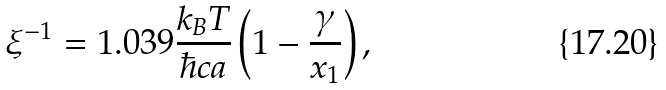Convert formula to latex. <formula><loc_0><loc_0><loc_500><loc_500>\xi ^ { - 1 } = 1 . 0 3 9 \frac { k _ { B } T } { \hbar { c } a } \left ( 1 - \frac { \gamma } { x _ { 1 } } \right ) ,</formula> 